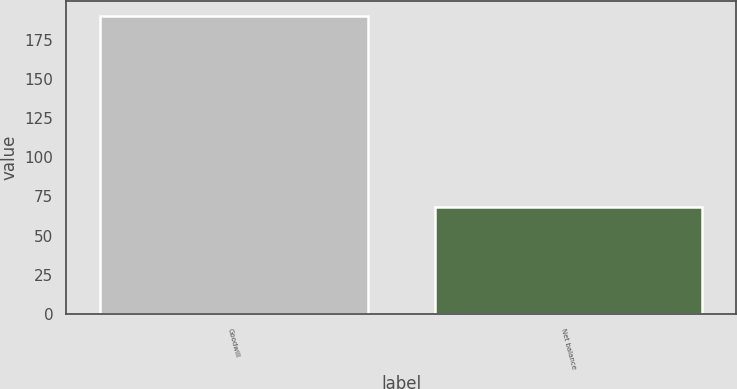<chart> <loc_0><loc_0><loc_500><loc_500><bar_chart><fcel>Goodwill<fcel>Net balance<nl><fcel>190<fcel>68<nl></chart> 